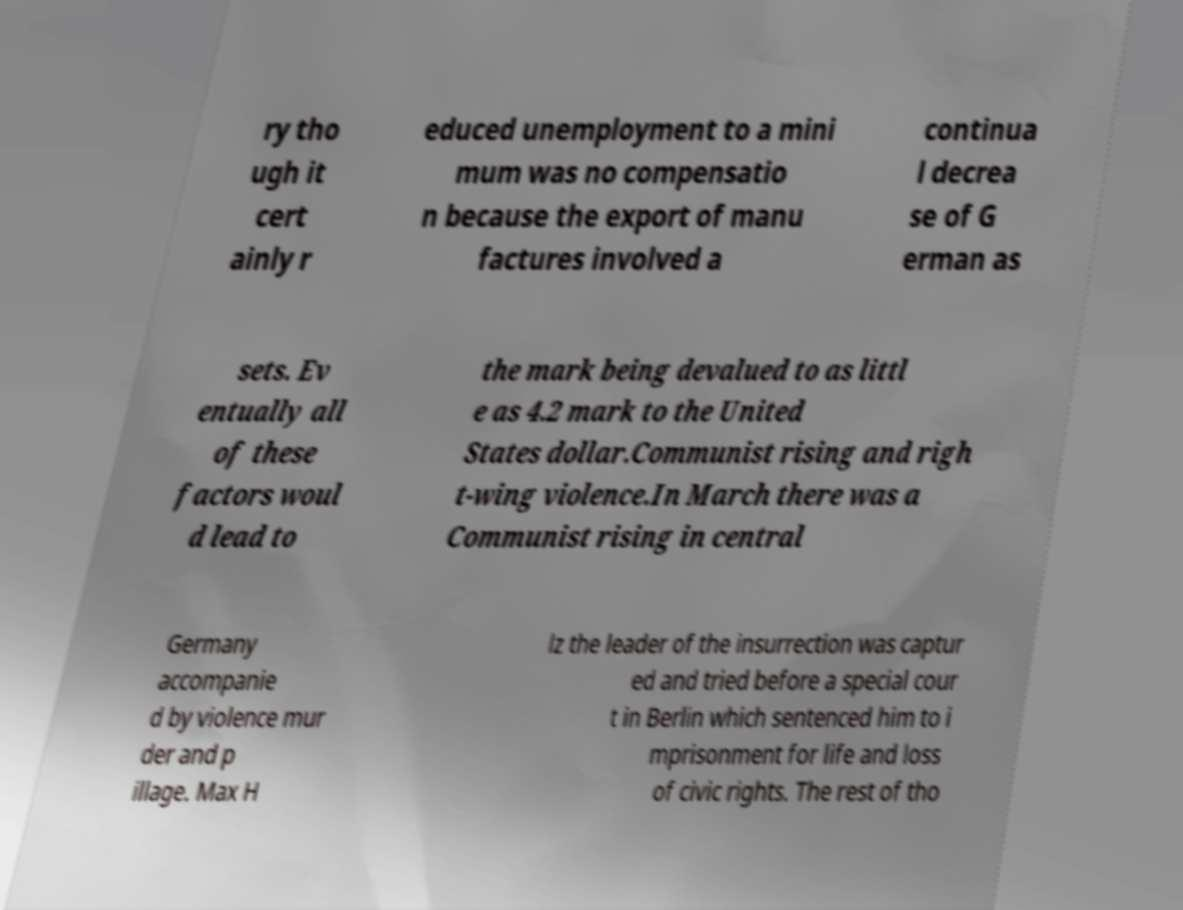Could you assist in decoding the text presented in this image and type it out clearly? ry tho ugh it cert ainly r educed unemployment to a mini mum was no compensatio n because the export of manu factures involved a continua l decrea se of G erman as sets. Ev entually all of these factors woul d lead to the mark being devalued to as littl e as 4.2 mark to the United States dollar.Communist rising and righ t-wing violence.In March there was a Communist rising in central Germany accompanie d by violence mur der and p illage. Max H lz the leader of the insurrection was captur ed and tried before a special cour t in Berlin which sentenced him to i mprisonment for life and loss of civic rights. The rest of tho 